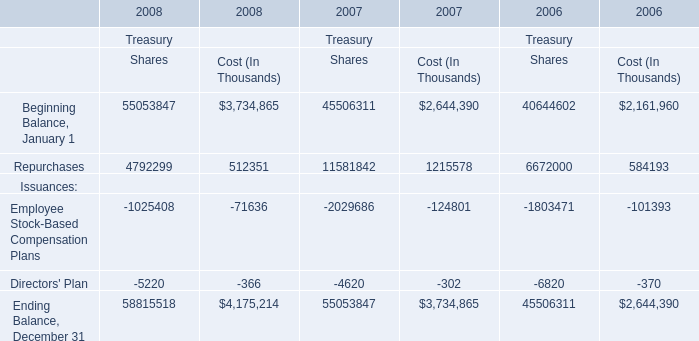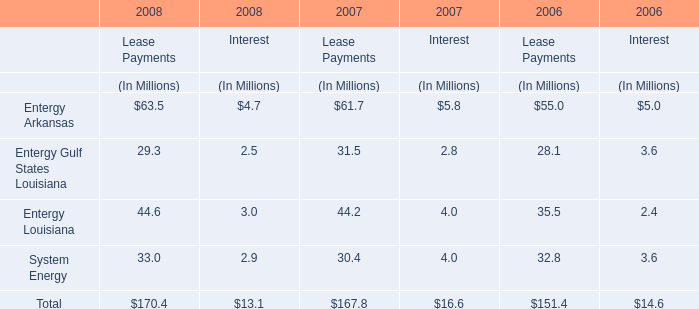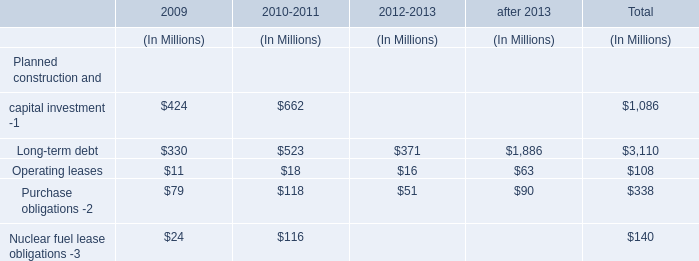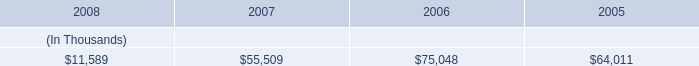Does Repurchases for Cost keeps increasing each year between 2007 and 2008? 
Answer: No. 